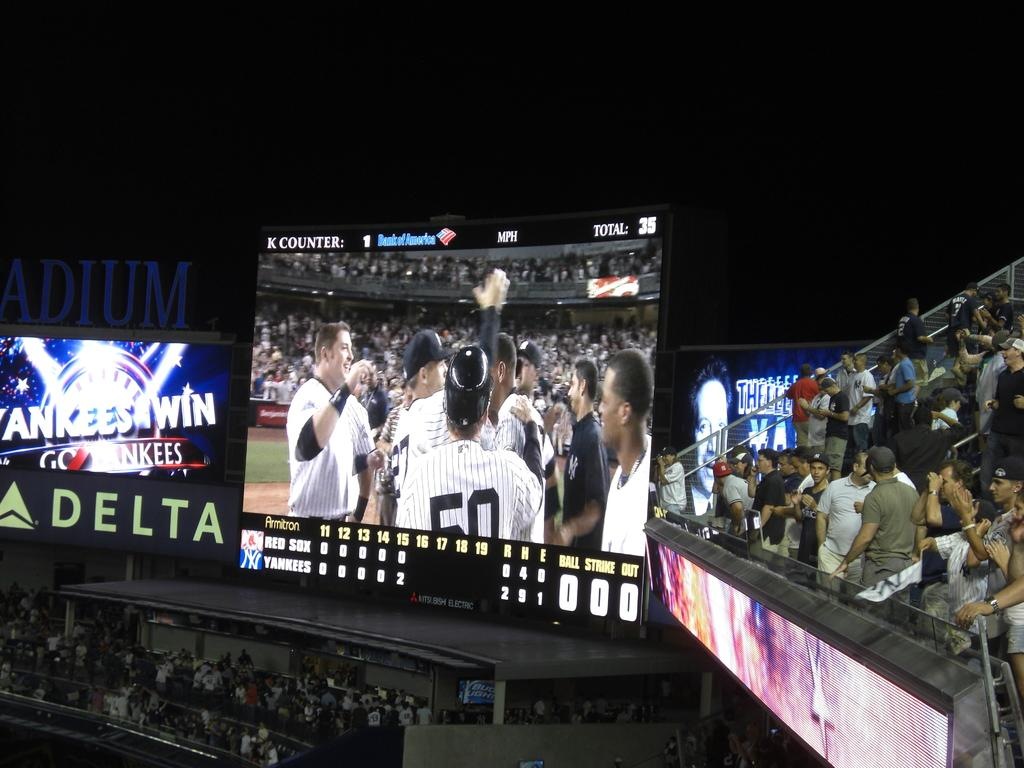<image>
Create a compact narrative representing the image presented. a baseball stadium screen at night with the game below, signage says Yankees Win with Delta advertised underneath. 